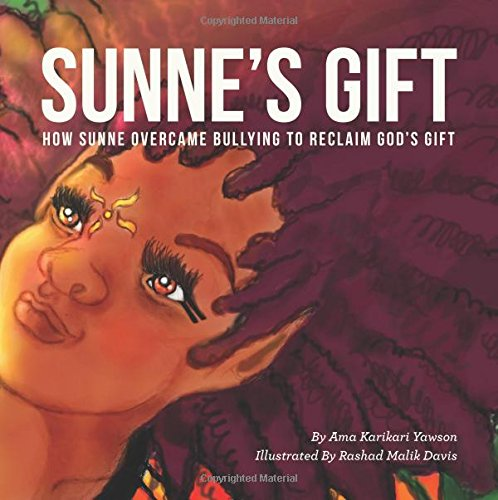How might this book be useful in a classroom setting? This book can be very beneficial in a classroom setting by serving as a tool for discussions about diversity, empathy, and emotional growth. It can help teachers address sensitive topics like bullying in a relatable and impactful way. 